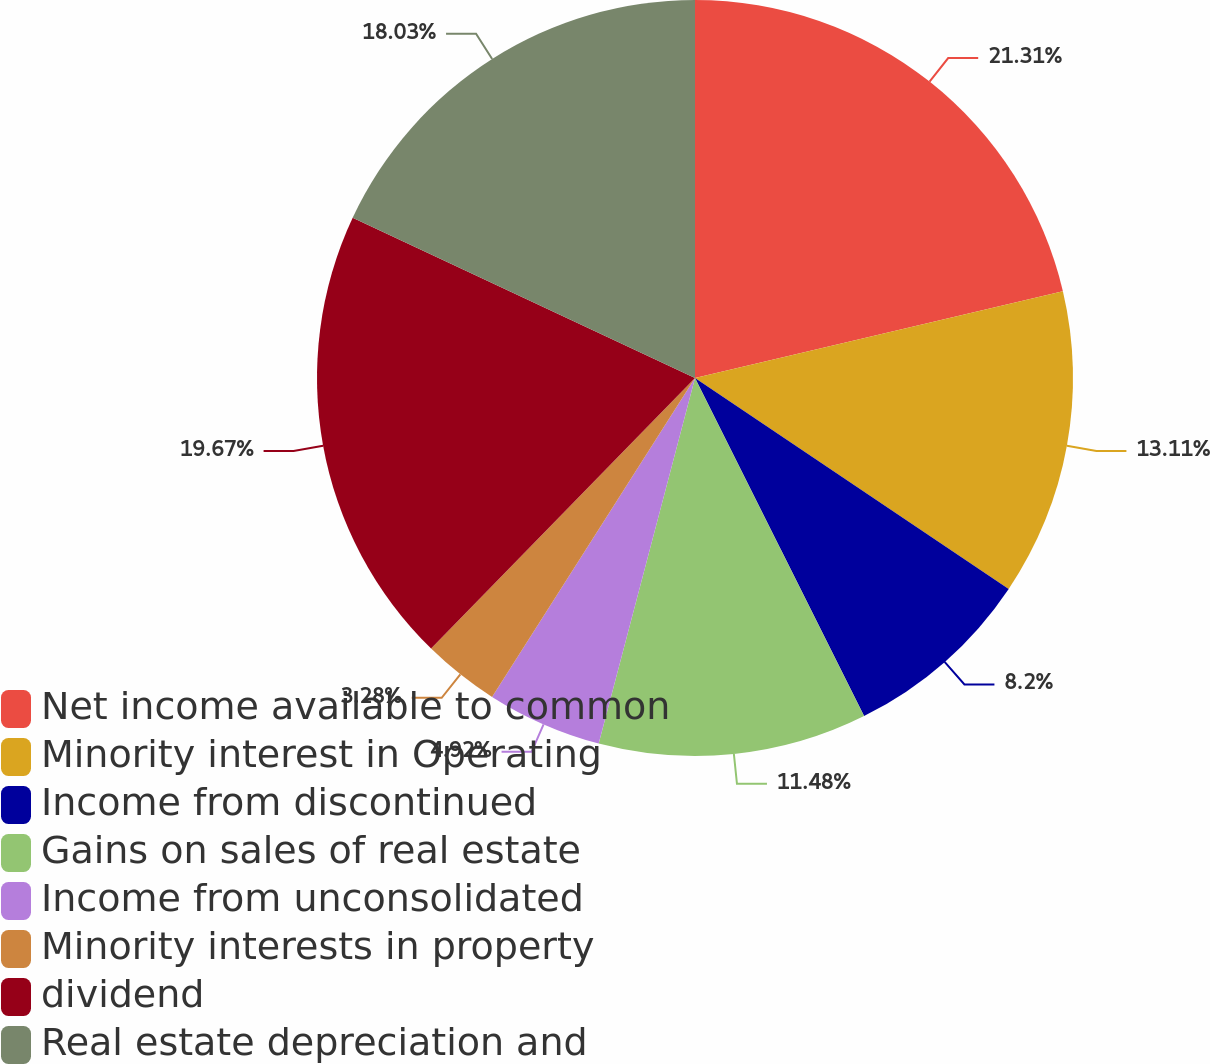Convert chart. <chart><loc_0><loc_0><loc_500><loc_500><pie_chart><fcel>Net income available to common<fcel>Minority interest in Operating<fcel>Income from discontinued<fcel>Gains on sales of real estate<fcel>Income from unconsolidated<fcel>Minority interests in property<fcel>dividend<fcel>Real estate depreciation and<nl><fcel>21.31%<fcel>13.11%<fcel>8.2%<fcel>11.48%<fcel>4.92%<fcel>3.28%<fcel>19.67%<fcel>18.03%<nl></chart> 